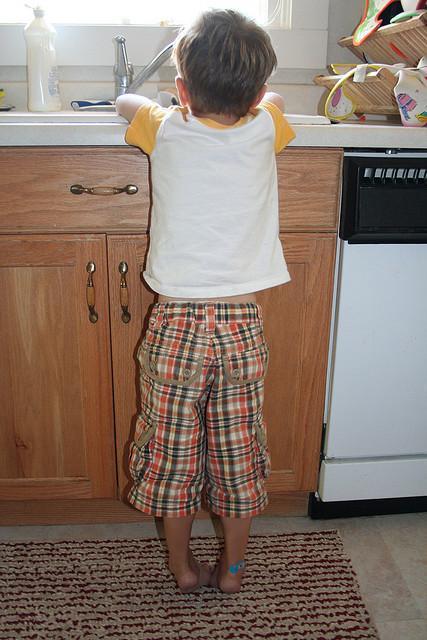How many boys are there?
Give a very brief answer. 1. How many horses are eating grass?
Give a very brief answer. 0. 